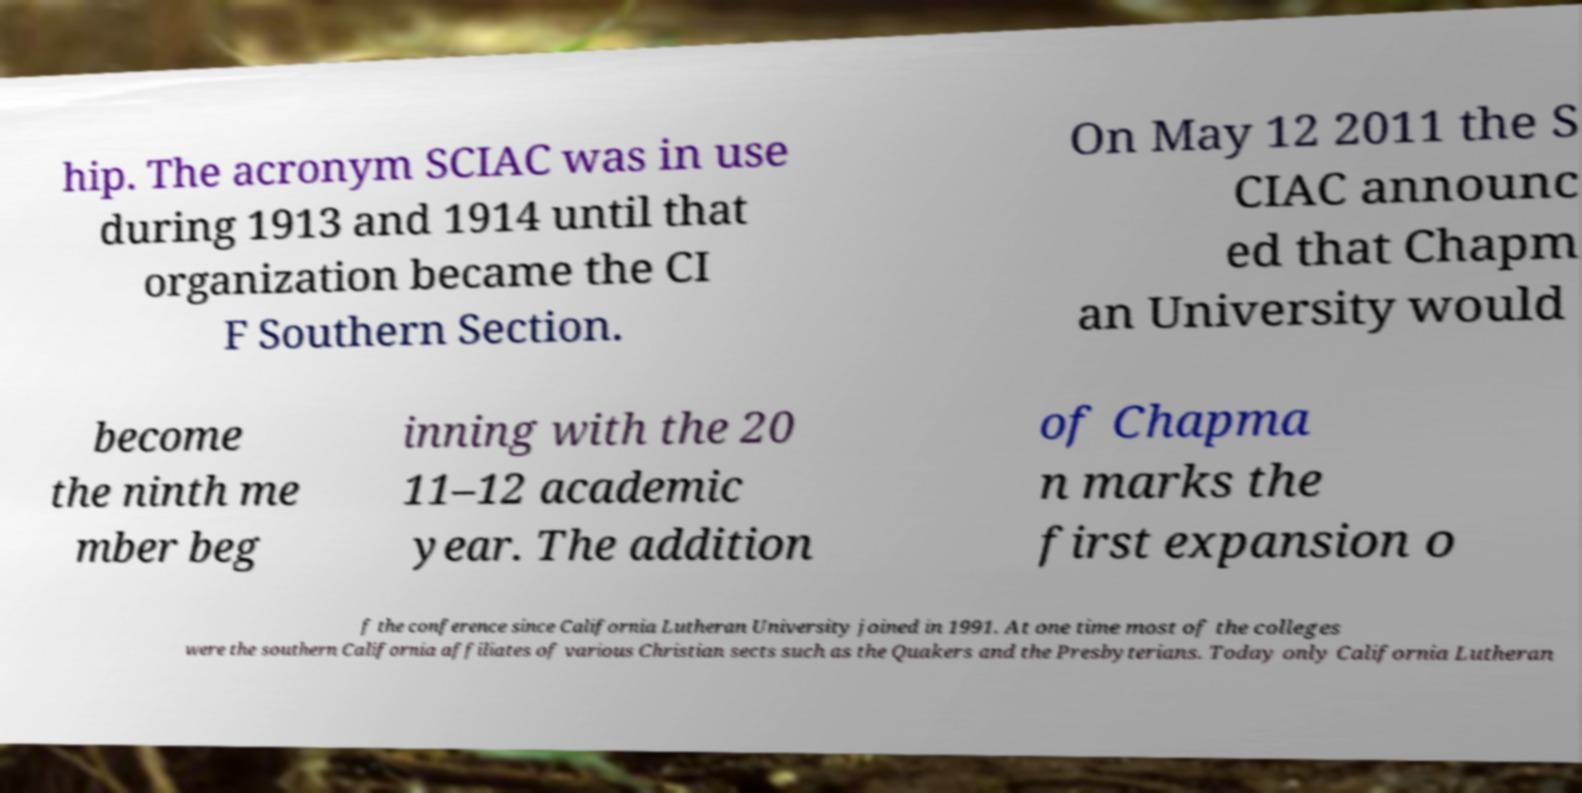For documentation purposes, I need the text within this image transcribed. Could you provide that? hip. The acronym SCIAC was in use during 1913 and 1914 until that organization became the CI F Southern Section. On May 12 2011 the S CIAC announc ed that Chapm an University would become the ninth me mber beg inning with the 20 11–12 academic year. The addition of Chapma n marks the first expansion o f the conference since California Lutheran University joined in 1991. At one time most of the colleges were the southern California affiliates of various Christian sects such as the Quakers and the Presbyterians. Today only California Lutheran 